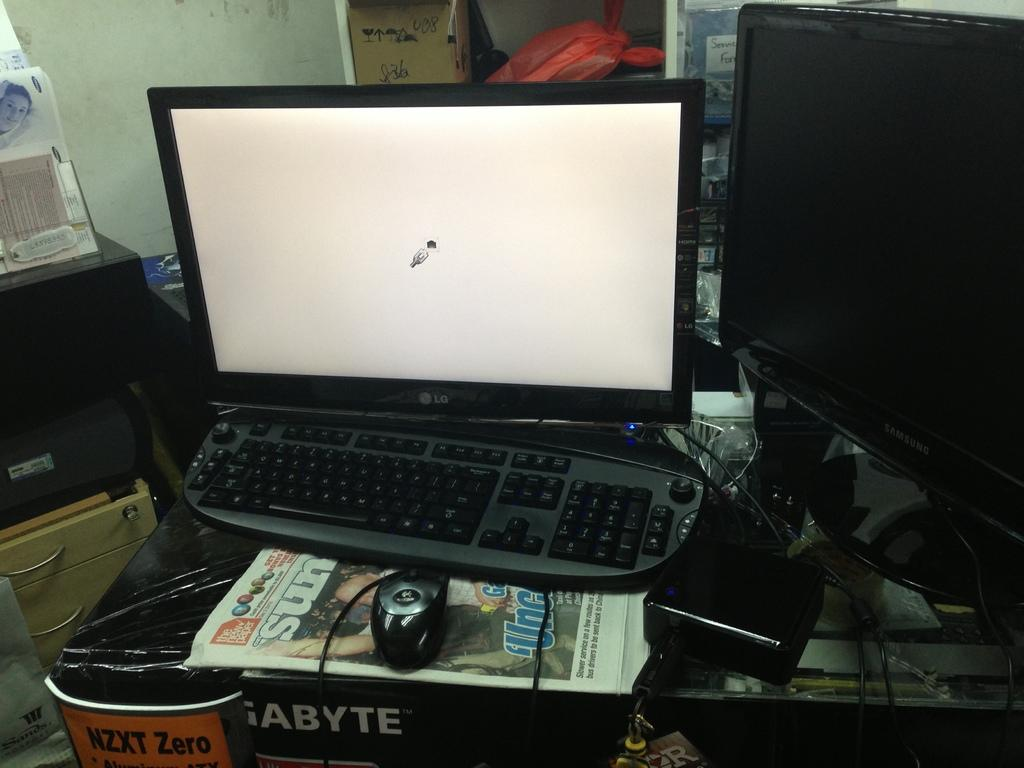<image>
Write a terse but informative summary of the picture. An LG desktop computer with The Sun newspaper underneath it. 